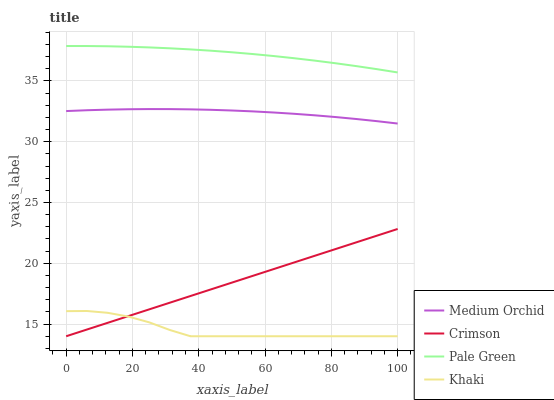Does Khaki have the minimum area under the curve?
Answer yes or no. Yes. Does Pale Green have the maximum area under the curve?
Answer yes or no. Yes. Does Medium Orchid have the minimum area under the curve?
Answer yes or no. No. Does Medium Orchid have the maximum area under the curve?
Answer yes or no. No. Is Crimson the smoothest?
Answer yes or no. Yes. Is Khaki the roughest?
Answer yes or no. Yes. Is Pale Green the smoothest?
Answer yes or no. No. Is Pale Green the roughest?
Answer yes or no. No. Does Crimson have the lowest value?
Answer yes or no. Yes. Does Medium Orchid have the lowest value?
Answer yes or no. No. Does Pale Green have the highest value?
Answer yes or no. Yes. Does Medium Orchid have the highest value?
Answer yes or no. No. Is Khaki less than Medium Orchid?
Answer yes or no. Yes. Is Medium Orchid greater than Crimson?
Answer yes or no. Yes. Does Khaki intersect Crimson?
Answer yes or no. Yes. Is Khaki less than Crimson?
Answer yes or no. No. Is Khaki greater than Crimson?
Answer yes or no. No. Does Khaki intersect Medium Orchid?
Answer yes or no. No. 